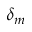<formula> <loc_0><loc_0><loc_500><loc_500>\delta _ { m }</formula> 